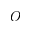<formula> <loc_0><loc_0><loc_500><loc_500>O</formula> 